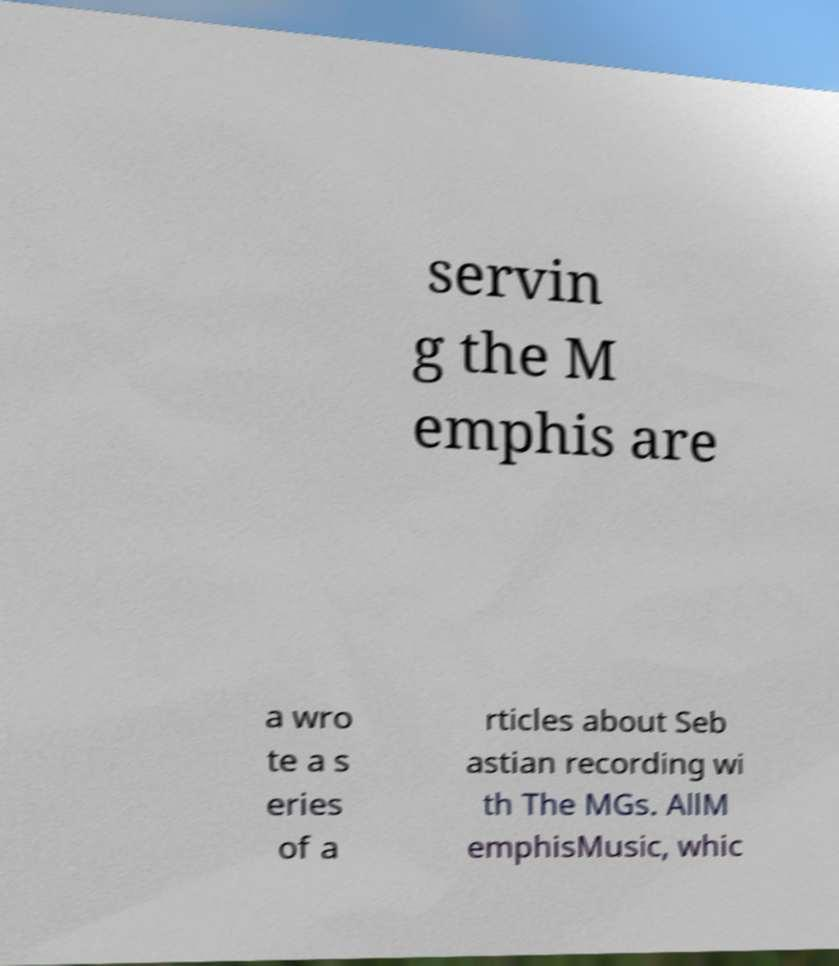Could you extract and type out the text from this image? servin g the M emphis are a wro te a s eries of a rticles about Seb astian recording wi th The MGs. AllM emphisMusic, whic 